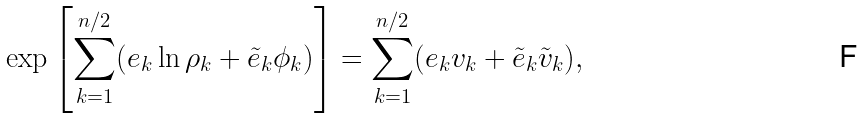Convert formula to latex. <formula><loc_0><loc_0><loc_500><loc_500>\exp \left [ \sum _ { k = 1 } ^ { n / 2 } ( e _ { k } \ln \rho _ { k } + \tilde { e } _ { k } \phi _ { k } ) \right ] = \sum _ { k = 1 } ^ { n / 2 } ( e _ { k } v _ { k } + \tilde { e } _ { k } \tilde { v } _ { k } ) ,</formula> 